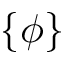Convert formula to latex. <formula><loc_0><loc_0><loc_500><loc_500>\{ \phi \}</formula> 